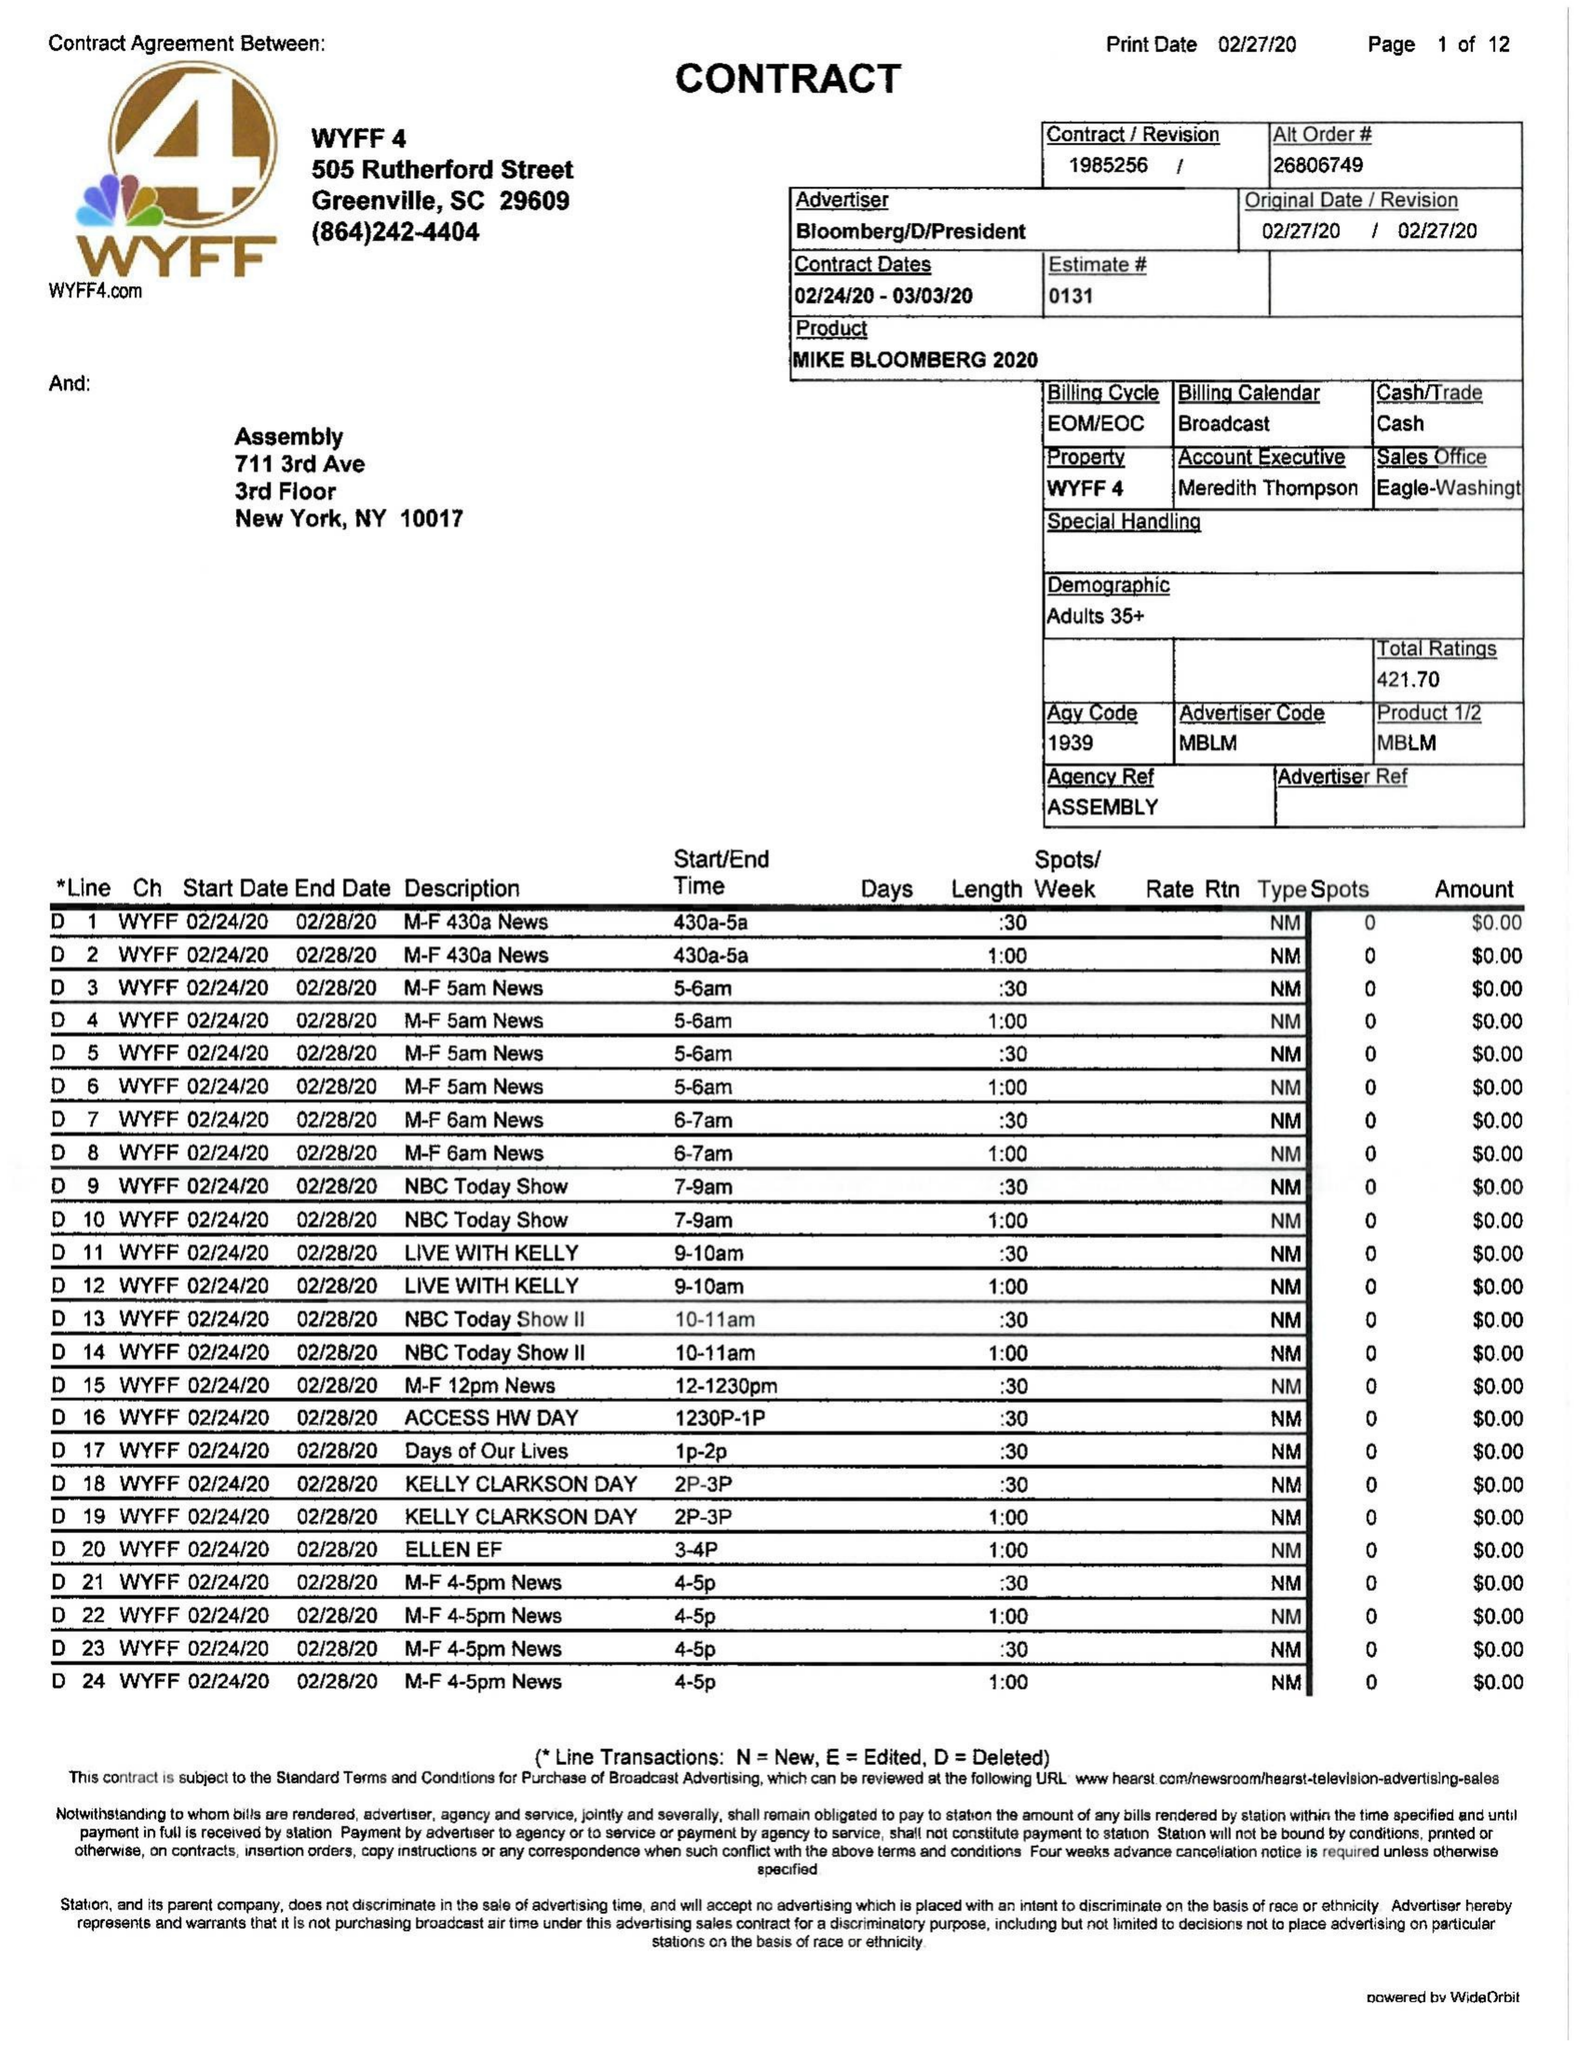What is the value for the advertiser?
Answer the question using a single word or phrase. BLOOMBERG/D/PRESIDENT 